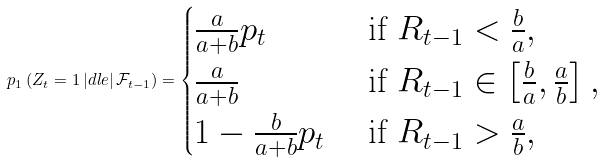Convert formula to latex. <formula><loc_0><loc_0><loc_500><loc_500>\ p _ { 1 } \left ( Z _ { t } = 1 \, | d l e | \, \mathcal { F } _ { t - 1 } \right ) = \begin{cases} \frac { a } { a + b } p _ { t } & \text { if } R _ { t - 1 } < \frac { b } { a } , \\ \frac { a } { a + b } & \text { if } R _ { t - 1 } \in \left [ \frac { b } { a } , \frac { a } { b } \right ] , \\ 1 - \frac { b } { a + b } p _ { t } & \text { if } R _ { t - 1 } > \frac { a } { b } , \end{cases}</formula> 